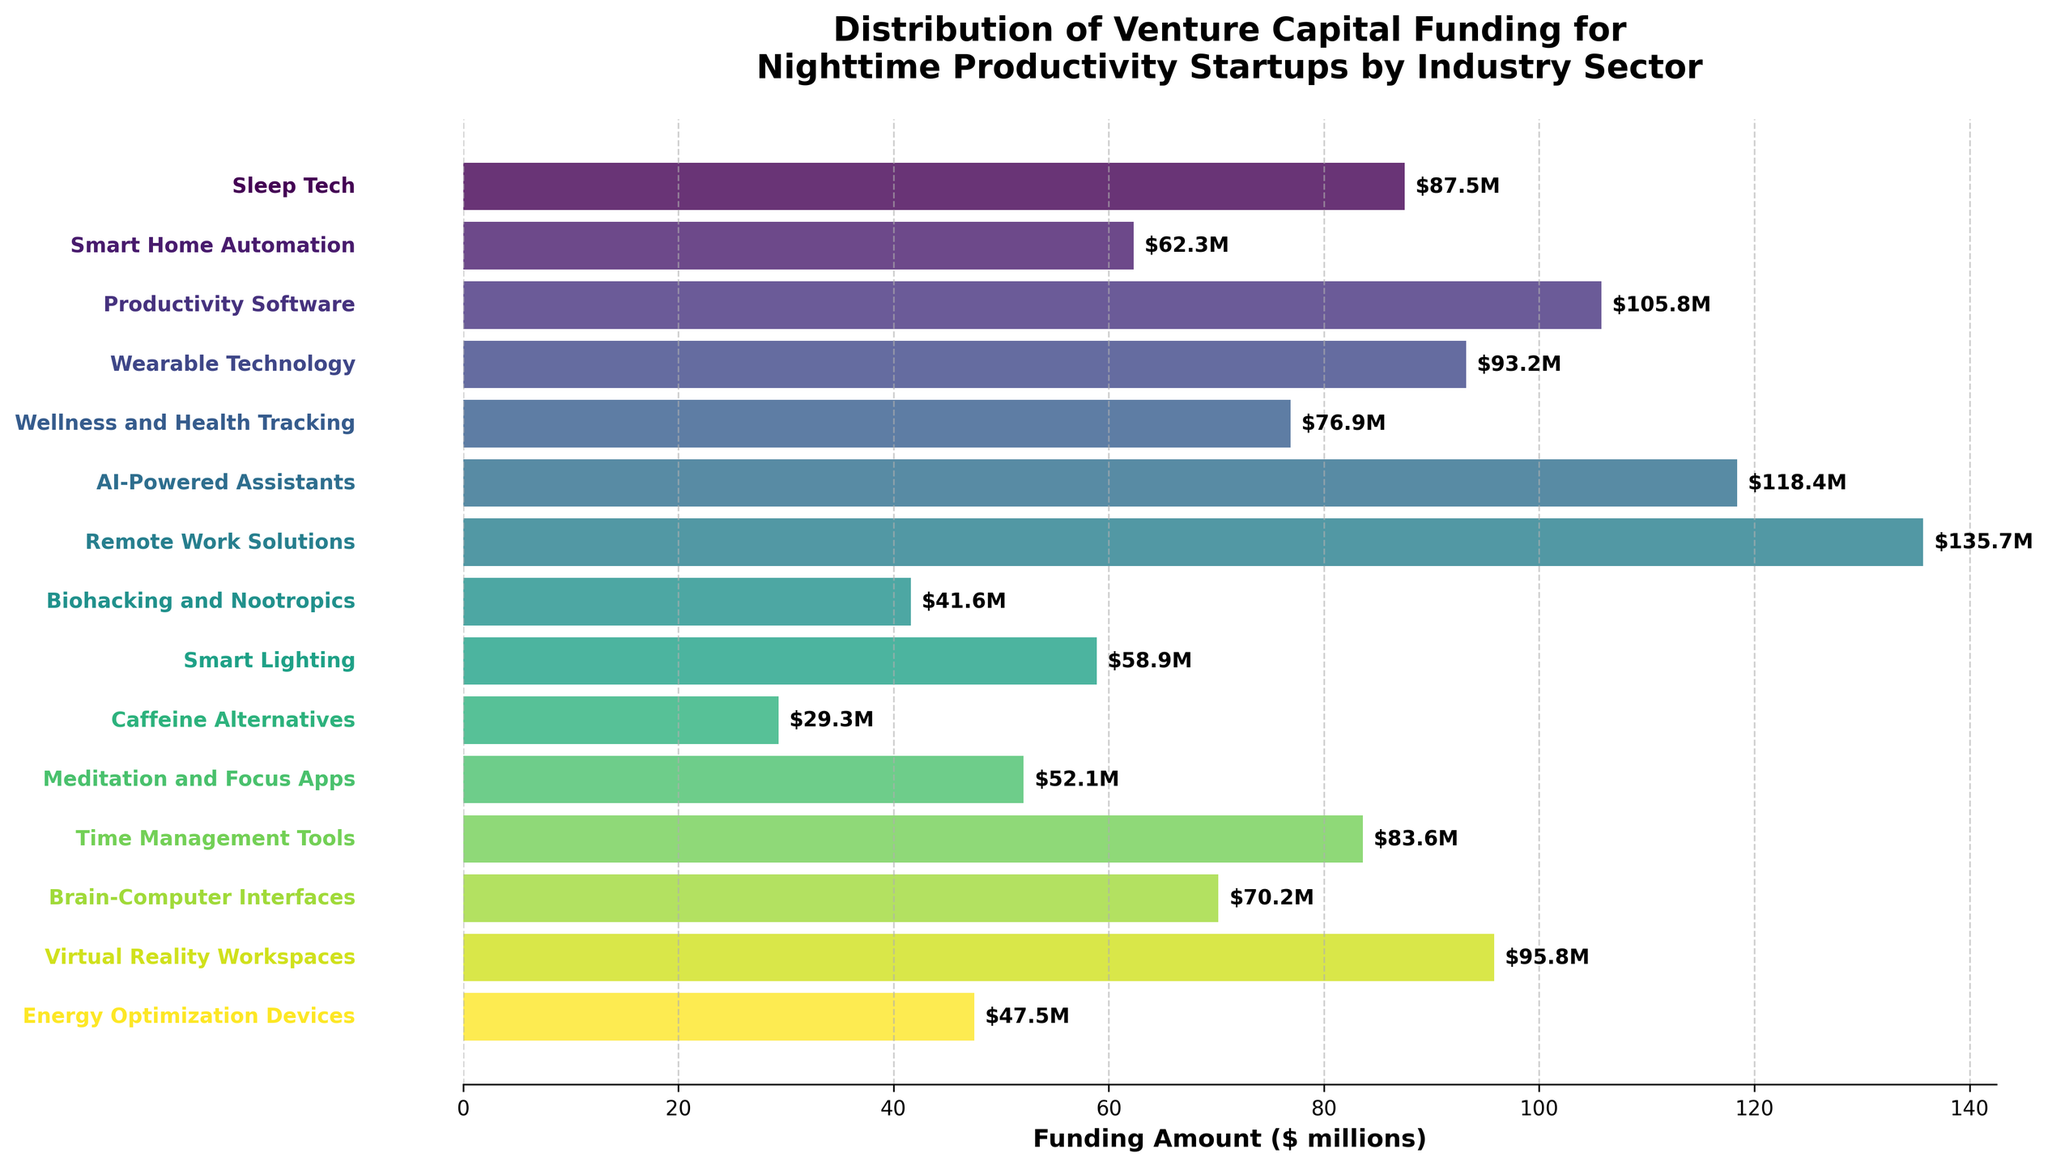Which industry sector received the highest amount of venture capital funding? The figure shows 'Remote Work Solutions' with the highest bar and a label indicating $135.7 million.
Answer: Remote Work Solutions Which industry sector received the lowest amount of funding? The figure shows 'Caffeine Alternatives' with the shortest bar and a label indicating $29.3 million.
Answer: Caffeine Alternatives How much more funding did 'AI-Powered Assistants' receive compared to 'Productivity Software'? The figure shows 'AI-Powered Assistants' received $118.4 million and 'Productivity Software' received $105.8 million. Subtracting the two amounts gives $118.4 - $105.8 = $12.6 million.
Answer: $12.6 million What is the average funding amount across all sectors? Sum all the funding amounts and divide by the number of sectors. This involves summing (87.5 + 62.3 + 105.8 + 93.2 + 76.9 + 118.4 + 135.7 + 41.6 + 58.9 + 29.3 + 52.1 + 83.6 + 70.2 + 95.8 + 47.5) = $1059.8 million. There are 15 sectors, so the average is $1059.8 / 15 = $70.65 million.
Answer: $70.65 million Which two sectors are closest in terms of funding amounts, and what is the difference? The figure shows 'Smart Home Automation' at $62.3 million and 'Smart Lighting' at $58.9 million. The difference is $62.3 - $58.9 = $3.4 million.
Answer: Smart Home Automation and Smart Lighting, $3.4 million What is the total amount of venture capital funding received by sectors related to 'Work Solutions' (Remote Work Solutions, Time Management Tools, Virtual Reality Workspaces)? Add the amounts for 'Remote Work Solutions' ($135.7 million), 'Time Management Tools' ($83.6 million), and 'Virtual Reality Workspaces' ($95.8 million). The total is $135.7 + $83.6 + $95.8 = $315.1 million.
Answer: $315.1 million Which sectors have funding amounts above $100 million? From the figure, 'Productivity Software' ($105.8 million), 'AI-Powered Assistants' ($118.4 million), and 'Remote Work Solutions' ($135.7 million) have funding amounts above $100 million.
Answer: Productivity Software, AI-Powered Assistants, Remote Work Solutions What is the median funding amount of all sectors? First, list the funding amounts in ascending order: 29.3, 41.6, 47.5, 52.1, 58.9, 62.3, 70.2, 76.9, 83.6, 87.5, 93.2, 95.8, 105.8, 118.4, 135.7. The median is the middle value in this ordered list. The 8th value is $76.9 million.
Answer: $76.9 million How does 'Wearable Technology' compare to 'Brain-Computer Interfaces' in terms of funding? The figure shows 'Wearable Technology' received $93.2 million and 'Brain-Computer Interfaces' received $70.2 million. 'Wearable Technology' has $93.2 - $70.2 = $23 million more in funding.
Answer: $23 million more 